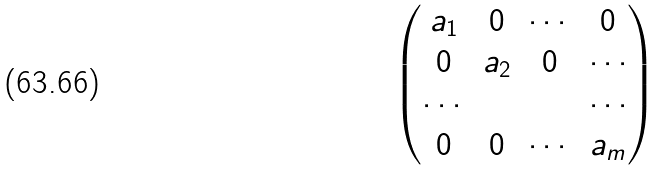Convert formula to latex. <formula><loc_0><loc_0><loc_500><loc_500>\begin{pmatrix} a _ { 1 } & 0 & \cdots & 0 \\ 0 & a _ { 2 } & 0 & \cdots \\ \cdots & & & \cdots \\ 0 & 0 & \cdots & a _ { m } \\ \end{pmatrix}</formula> 